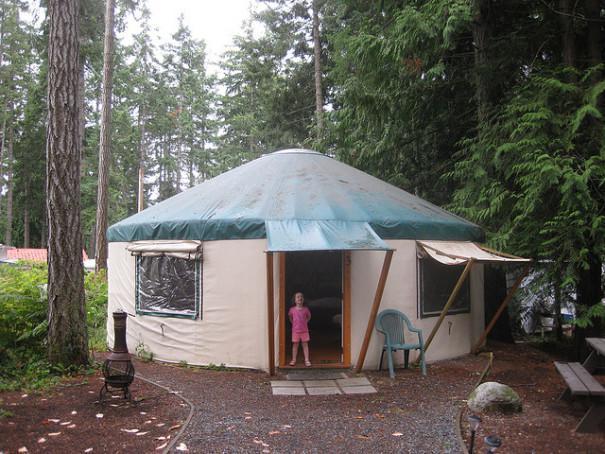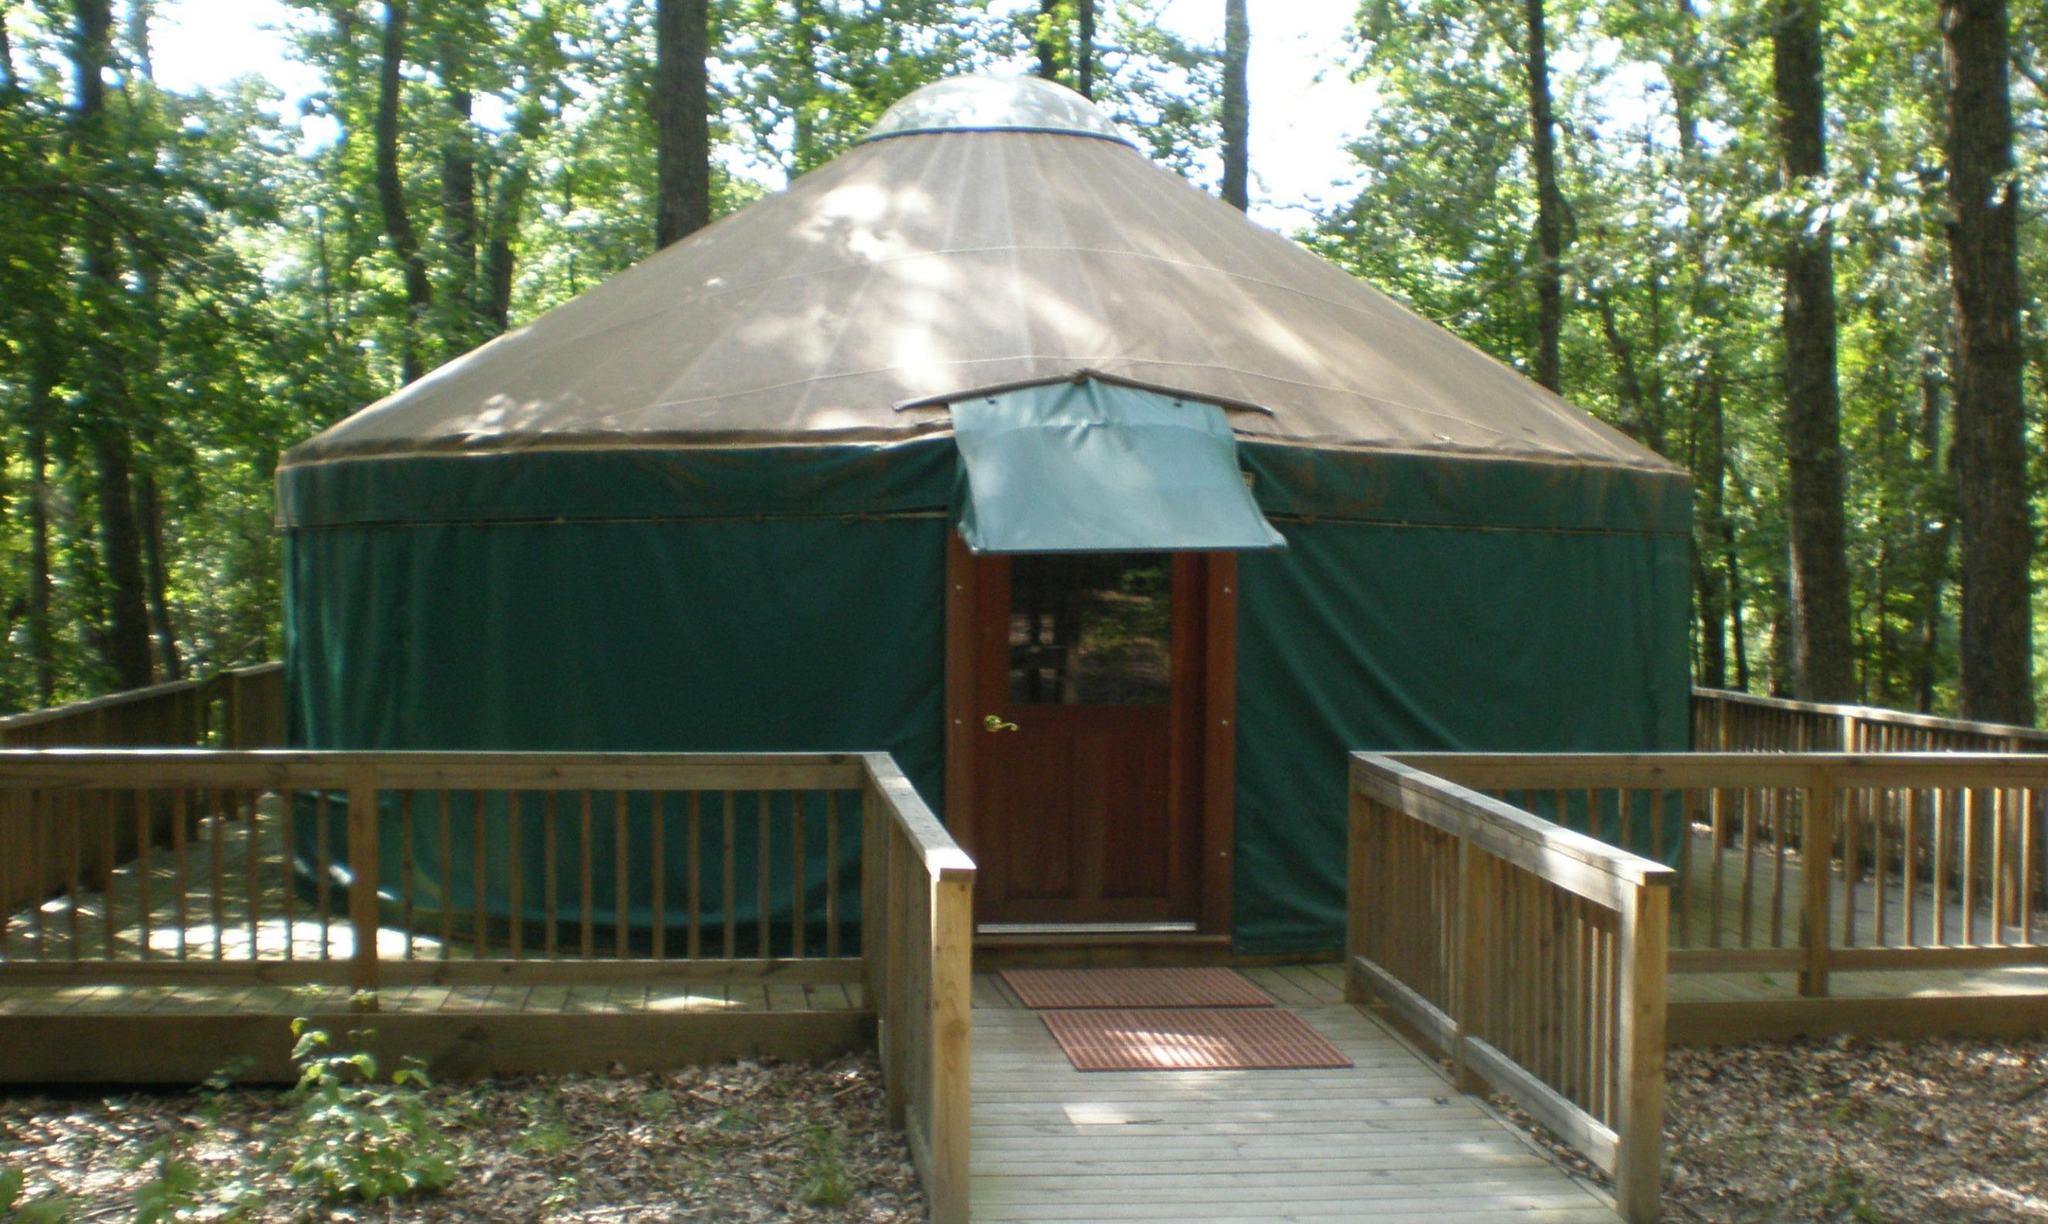The first image is the image on the left, the second image is the image on the right. Given the left and right images, does the statement "A dark green yurt with tan roof is surrounded by a wooden deck with railings, an opening directly in front of the yurt's entry door." hold true? Answer yes or no. Yes. The first image is the image on the left, the second image is the image on the right. For the images shown, is this caption "At least one yurt has a set of three or four wooden stairs that leads to the door." true? Answer yes or no. No. 